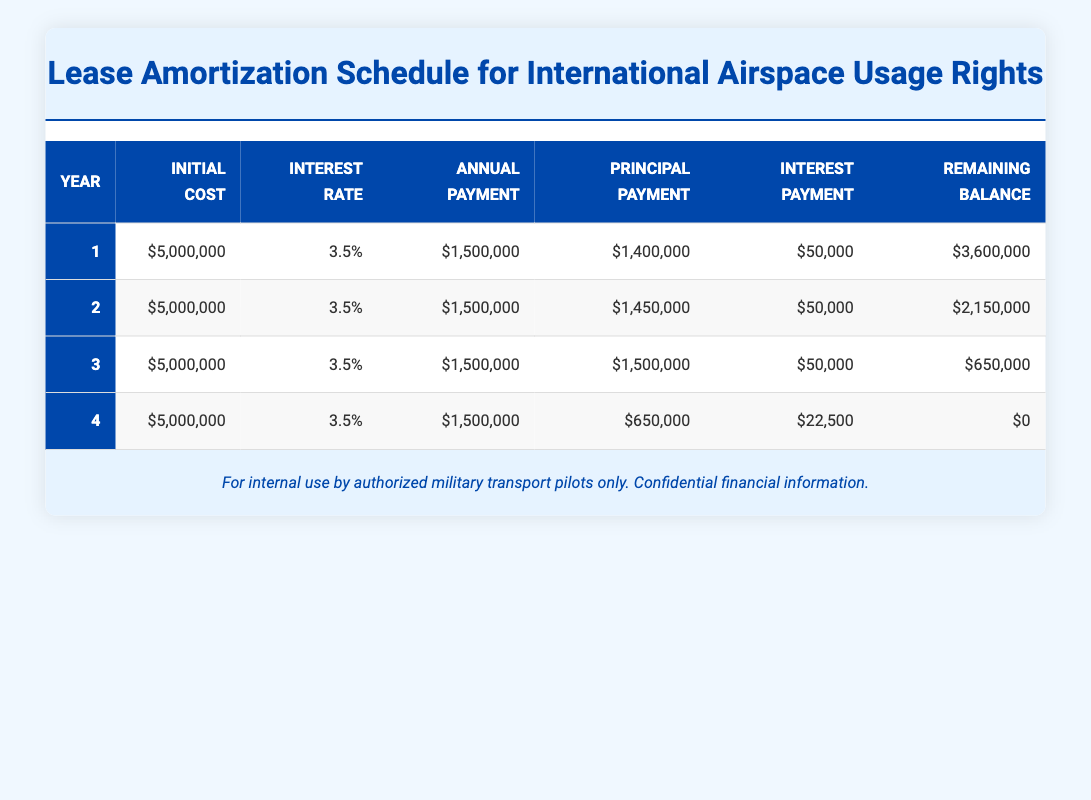What is the initial cost of the lease in each year? The initial cost is a constant value of 5,000,000 across all four years, as listed in the table.
Answer: 5,000,000 What is the principal payment for Year 3? The principal payment is specifically stated in Year 3 of the table, which shows a principal payment of 1,500,000.
Answer: 1,500,000 What is the total interest paid after Year 2? To find the total interest paid after Year 2, we add the interest payments for Year 1 and Year 2: 50,000 (Year 1) + 50,000 (Year 2) = 100,000.
Answer: 100,000 Is the remaining balance after Year 4 equal to zero? The remaining balance after Year 4 is recorded as 0, indicating that the lease has been fully amortized by the end of Year 4.
Answer: Yes What is the average annual payment across all four years? To calculate the average annual payment, sum the annual payments (1,500,000 for each of the 4 years) giving a total of 6,000,000, then divide by 4. Thus, 6,000,000 / 4 = 1,500,000.
Answer: 1,500,000 What is the difference in principal payment between Year 1 and Year 2? The principal payments are 1,400,000 for Year 1 and 1,450,000 for Year 2. The difference is calculated as: 1,450,000 - 1,400,000 = 50,000.
Answer: 50,000 How much interest will be paid in Year 4? For Year 4, the interest payment listed in the table is 22,500, which is specifically indicated next to the Year 4 row.
Answer: 22,500 What is the total principal payment over the four years? To find the total principal payment, add the principal payments from all four years: 1,400,000 + 1,450,000 + 1,500,000 + 650,000 = 5,000,000.
Answer: 5,000,000 Is the annual payment the same for all years? Yes, the annual payment is consistently recorded as 1,500,000 for each of the four years in the table.
Answer: Yes 